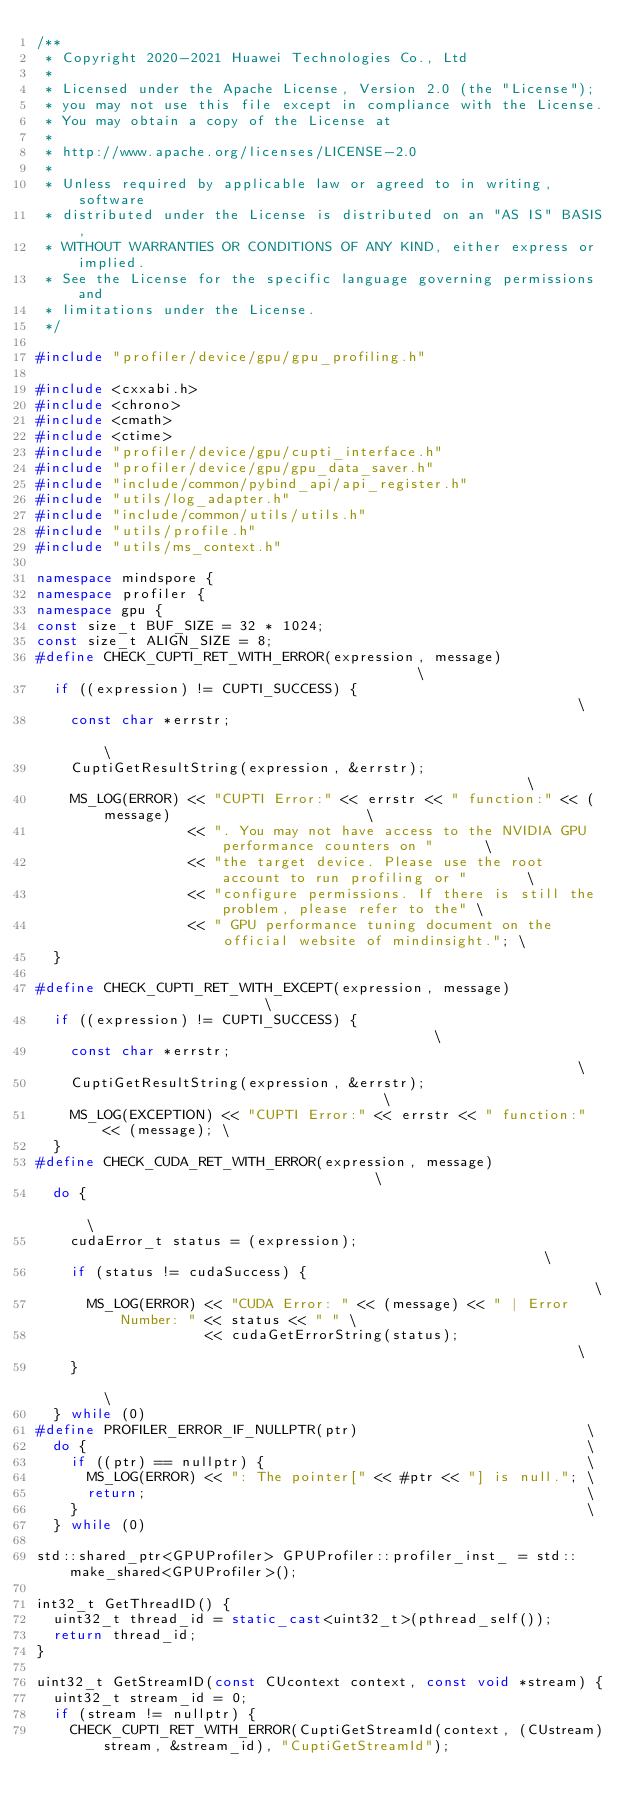Convert code to text. <code><loc_0><loc_0><loc_500><loc_500><_C++_>/**
 * Copyright 2020-2021 Huawei Technologies Co., Ltd
 *
 * Licensed under the Apache License, Version 2.0 (the "License");
 * you may not use this file except in compliance with the License.
 * You may obtain a copy of the License at
 *
 * http://www.apache.org/licenses/LICENSE-2.0
 *
 * Unless required by applicable law or agreed to in writing, software
 * distributed under the License is distributed on an "AS IS" BASIS,
 * WITHOUT WARRANTIES OR CONDITIONS OF ANY KIND, either express or implied.
 * See the License for the specific language governing permissions and
 * limitations under the License.
 */

#include "profiler/device/gpu/gpu_profiling.h"

#include <cxxabi.h>
#include <chrono>
#include <cmath>
#include <ctime>
#include "profiler/device/gpu/cupti_interface.h"
#include "profiler/device/gpu/gpu_data_saver.h"
#include "include/common/pybind_api/api_register.h"
#include "utils/log_adapter.h"
#include "include/common/utils/utils.h"
#include "utils/profile.h"
#include "utils/ms_context.h"

namespace mindspore {
namespace profiler {
namespace gpu {
const size_t BUF_SIZE = 32 * 1024;
const size_t ALIGN_SIZE = 8;
#define CHECK_CUPTI_RET_WITH_ERROR(expression, message)                                          \
  if ((expression) != CUPTI_SUCCESS) {                                                           \
    const char *errstr;                                                                          \
    CuptiGetResultString(expression, &errstr);                                                   \
    MS_LOG(ERROR) << "CUPTI Error:" << errstr << " function:" << (message)                       \
                  << ". You may not have access to the NVIDIA GPU performance counters on "      \
                  << "the target device. Please use the root account to run profiling or "       \
                  << "configure permissions. If there is still the problem, please refer to the" \
                  << " GPU performance tuning document on the official website of mindinsight."; \
  }

#define CHECK_CUPTI_RET_WITH_EXCEPT(expression, message)                        \
  if ((expression) != CUPTI_SUCCESS) {                                          \
    const char *errstr;                                                         \
    CuptiGetResultString(expression, &errstr);                                  \
    MS_LOG(EXCEPTION) << "CUPTI Error:" << errstr << " function:" << (message); \
  }
#define CHECK_CUDA_RET_WITH_ERROR(expression, message)                                     \
  do {                                                                                     \
    cudaError_t status = (expression);                                                     \
    if (status != cudaSuccess) {                                                           \
      MS_LOG(ERROR) << "CUDA Error: " << (message) << " | Error Number: " << status << " " \
                    << cudaGetErrorString(status);                                         \
    }                                                                                      \
  } while (0)
#define PROFILER_ERROR_IF_NULLPTR(ptr)                           \
  do {                                                           \
    if ((ptr) == nullptr) {                                      \
      MS_LOG(ERROR) << ": The pointer[" << #ptr << "] is null."; \
      return;                                                    \
    }                                                            \
  } while (0)

std::shared_ptr<GPUProfiler> GPUProfiler::profiler_inst_ = std::make_shared<GPUProfiler>();

int32_t GetThreadID() {
  uint32_t thread_id = static_cast<uint32_t>(pthread_self());
  return thread_id;
}

uint32_t GetStreamID(const CUcontext context, const void *stream) {
  uint32_t stream_id = 0;
  if (stream != nullptr) {
    CHECK_CUPTI_RET_WITH_ERROR(CuptiGetStreamId(context, (CUstream)stream, &stream_id), "CuptiGetStreamId");</code> 